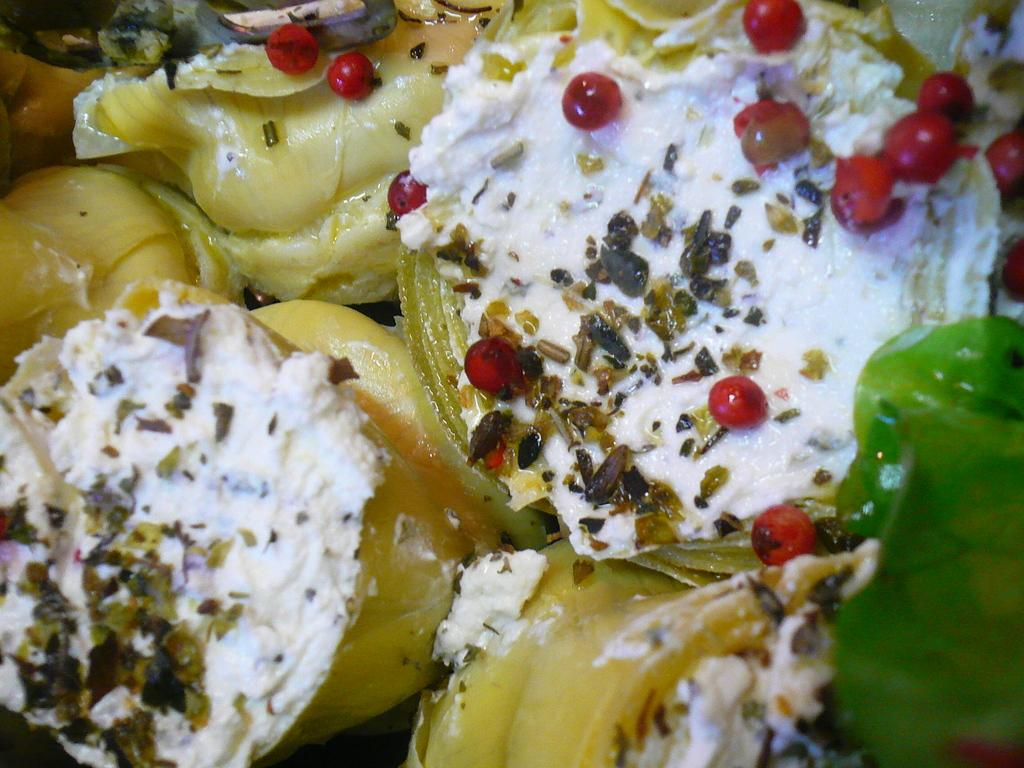What type of food is visible in the image? There is food in the image, but the specific type cannot be determined from the provided facts. What is the color of the cream on the food? The cream on the food is white-colored. What can be described as red-colored in the image? There are red-colored things in the image, but their specific nature cannot be determined from the provided facts. What scientific experiment is being conducted with the pickle in the image? There is no pickle present in the image, and therefore no scientific experiment can be observed. What type of competition is taking place in the image? There is no competition present in the image, and therefore no specific type of competition can be observed. 